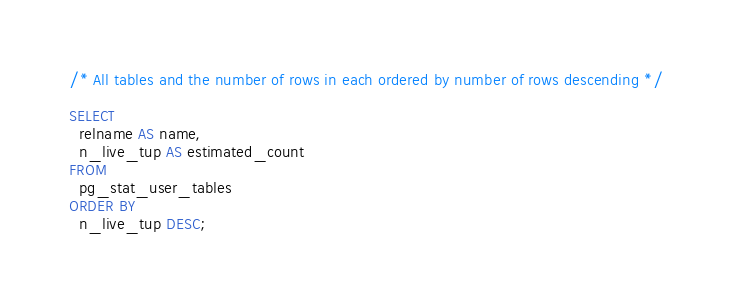<code> <loc_0><loc_0><loc_500><loc_500><_SQL_>/* All tables and the number of rows in each ordered by number of rows descending */

SELECT
  relname AS name,
  n_live_tup AS estimated_count
FROM
  pg_stat_user_tables
ORDER BY
  n_live_tup DESC;
</code> 